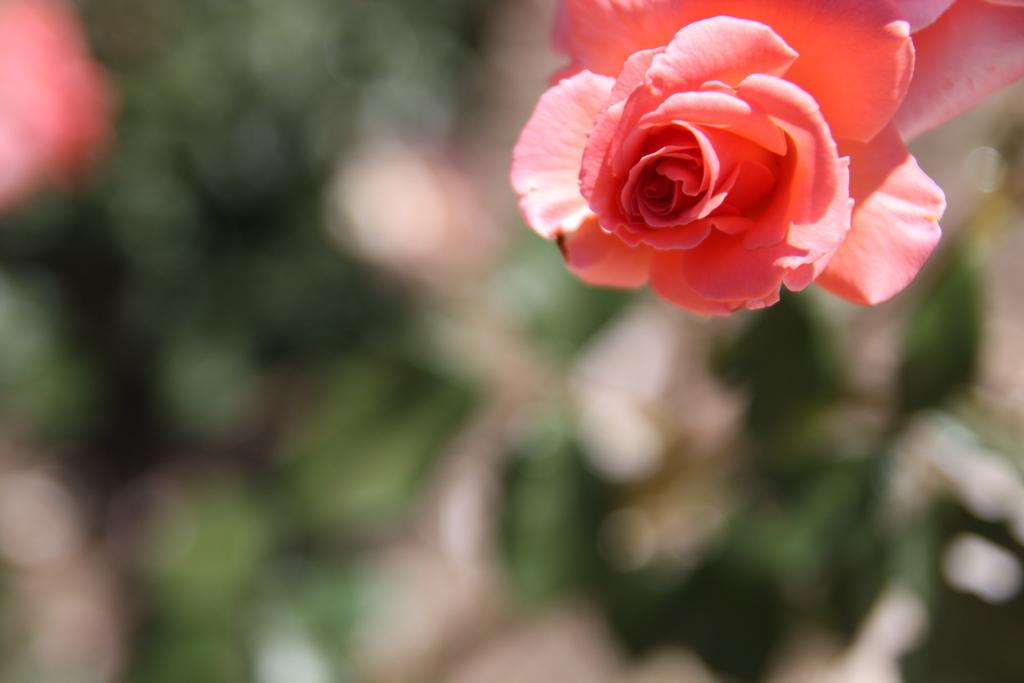What is the main subject of the image? There is a flower in the image. Can you describe the background of the image? The background of the image is blurred. What type of glove is being worn by the flower in the image? There is no glove present in the image, as it features a flower with a blurred background. 